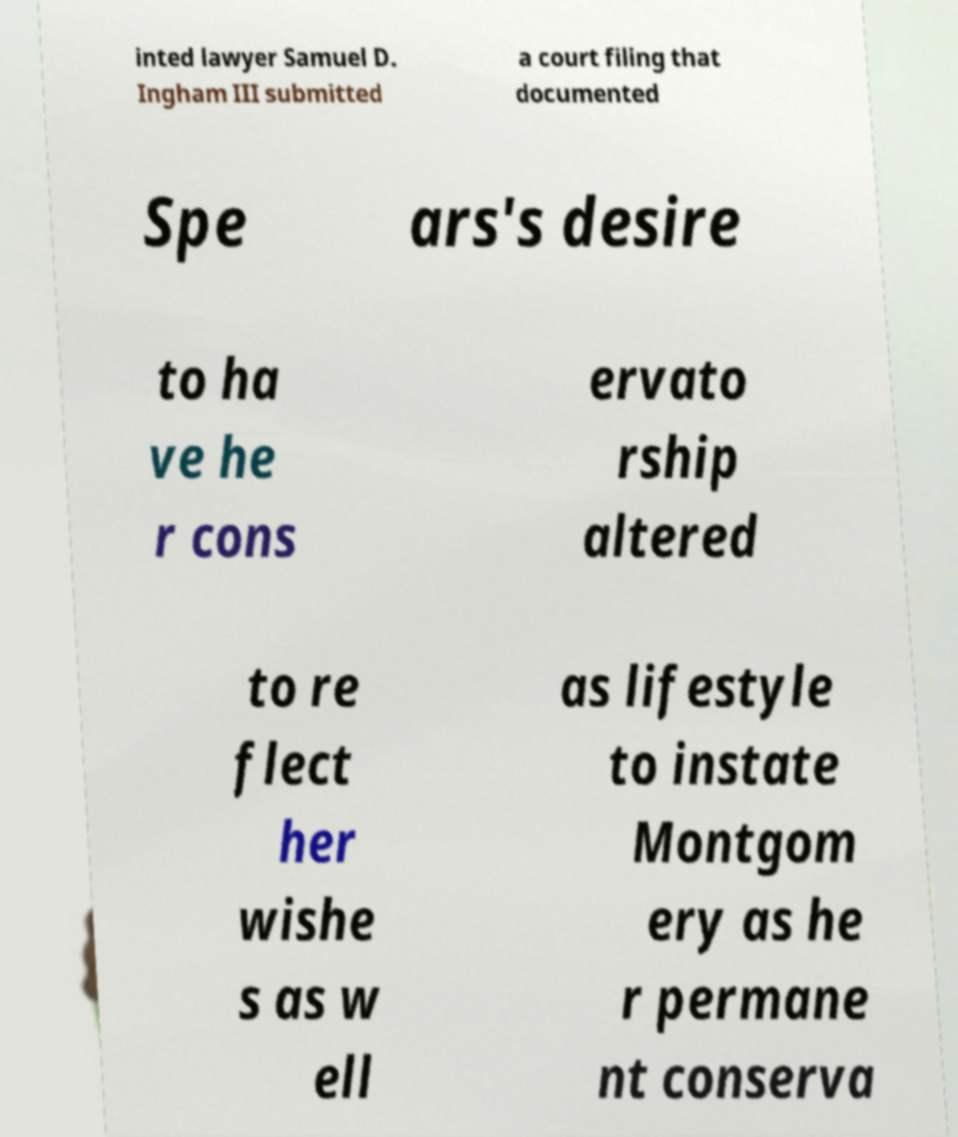What messages or text are displayed in this image? I need them in a readable, typed format. inted lawyer Samuel D. Ingham III submitted a court filing that documented Spe ars's desire to ha ve he r cons ervato rship altered to re flect her wishe s as w ell as lifestyle to instate Montgom ery as he r permane nt conserva 